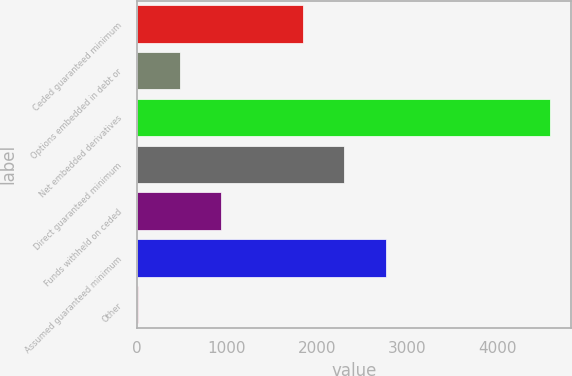Convert chart. <chart><loc_0><loc_0><loc_500><loc_500><bar_chart><fcel>Ceded guaranteed minimum<fcel>Options embedded in debt or<fcel>Net embedded derivatives<fcel>Direct guaranteed minimum<fcel>Funds withheld on ceded<fcel>Assumed guaranteed minimum<fcel>Other<nl><fcel>1844.4<fcel>474.6<fcel>4584<fcel>2301<fcel>931.2<fcel>2757.6<fcel>18<nl></chart> 